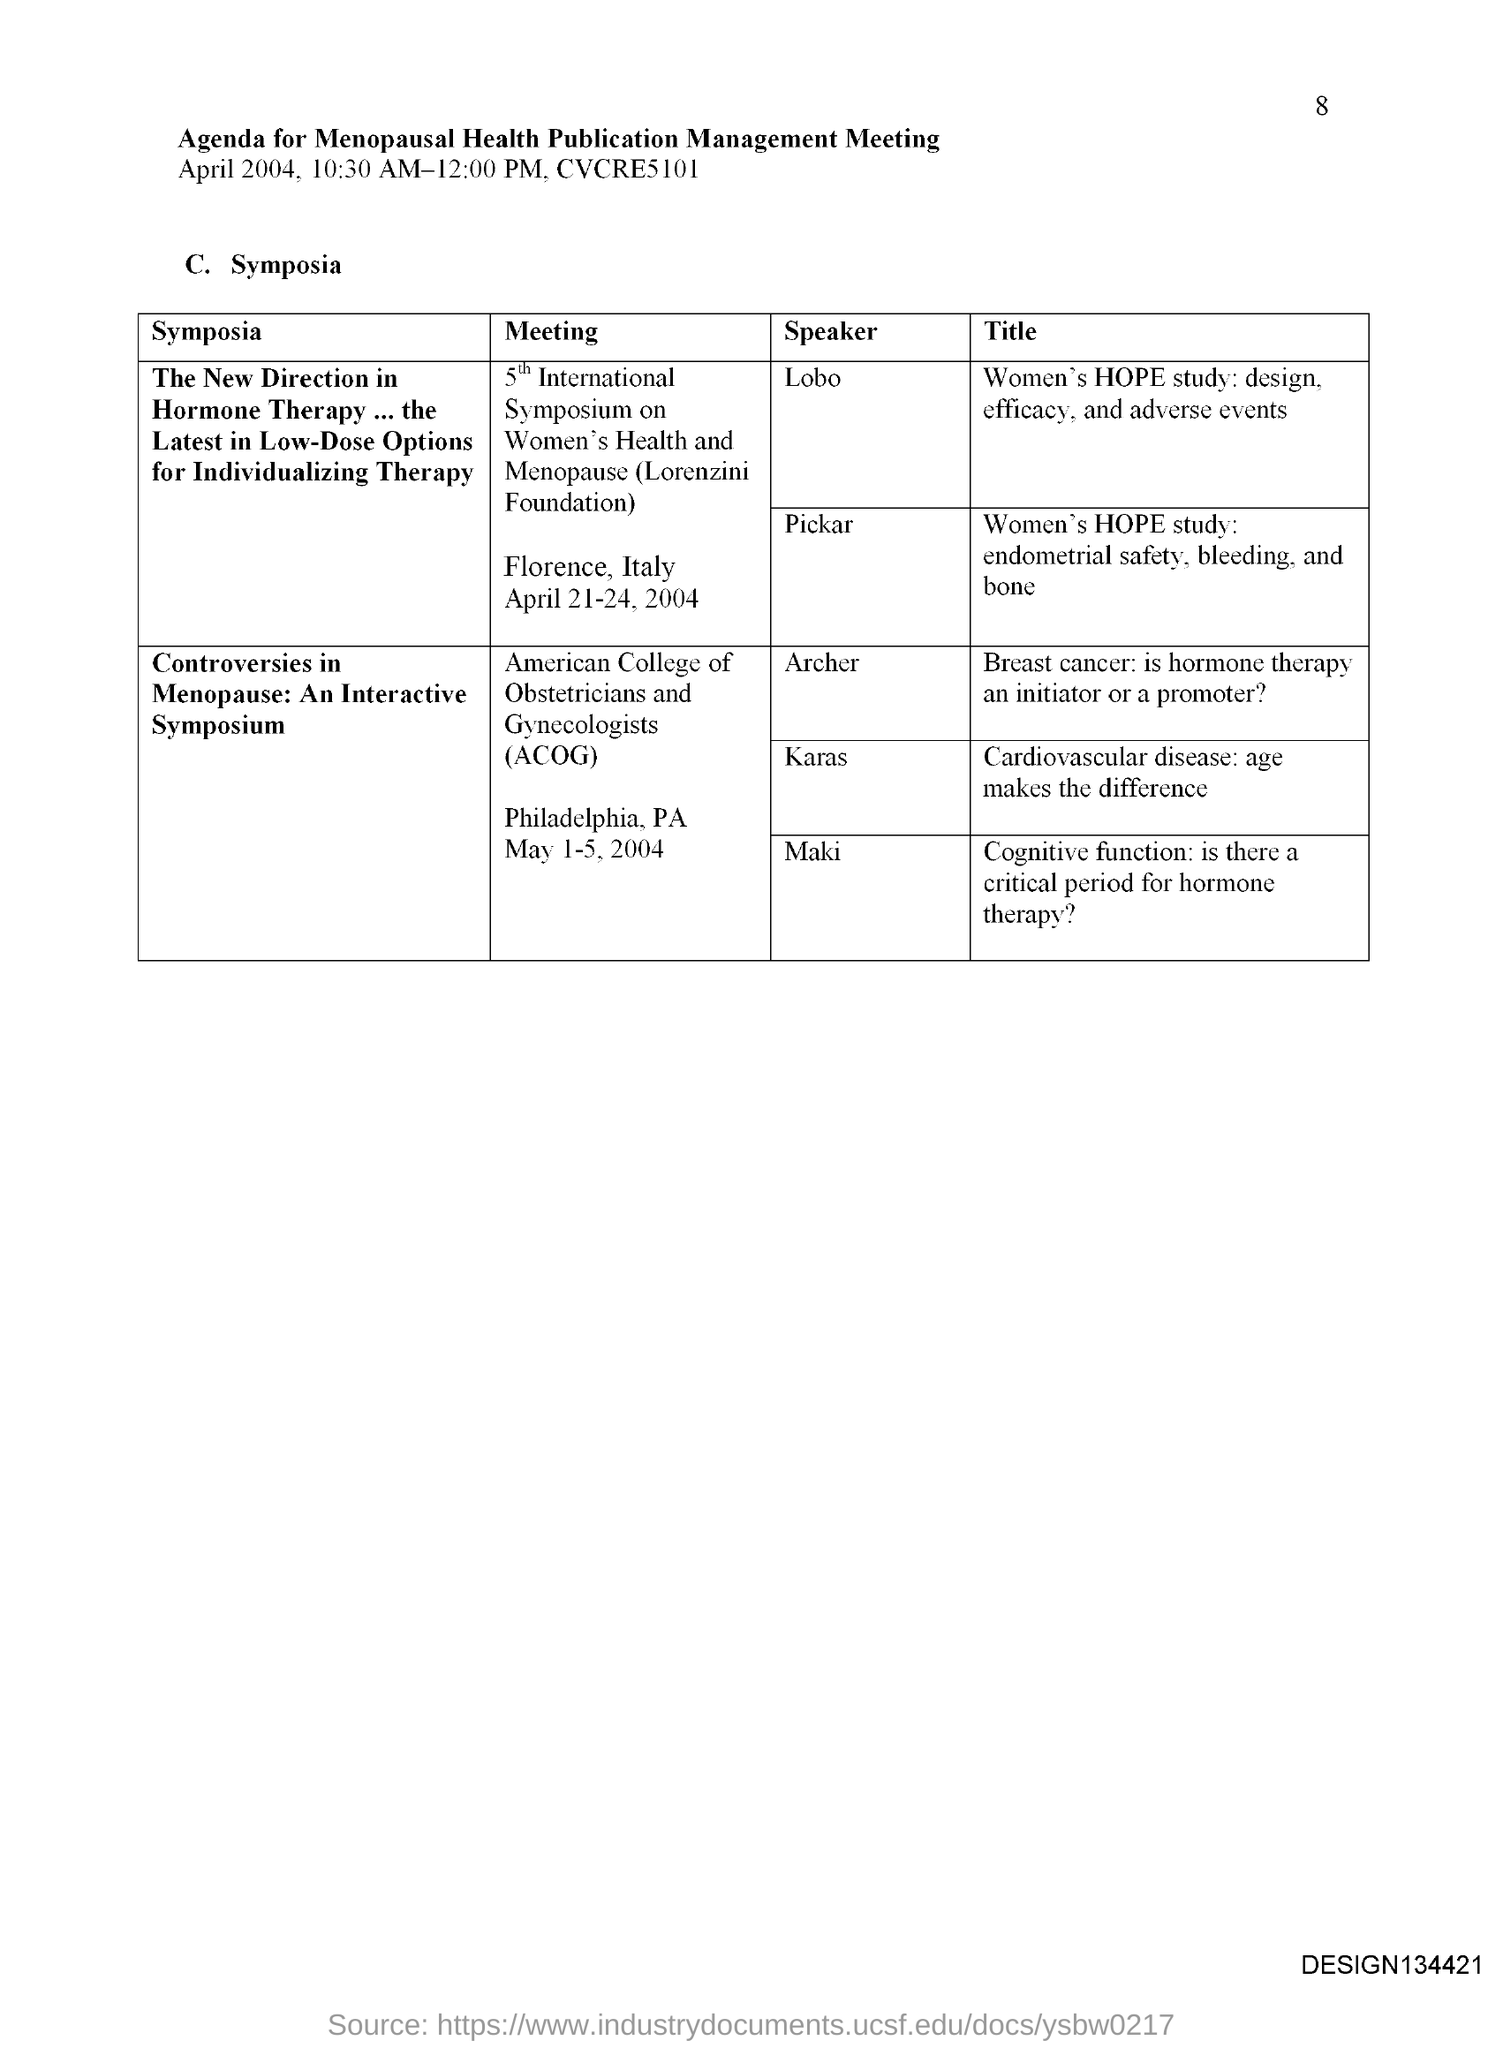What is the title of the document?
Make the answer very short. Agenda for Menopausal health publication management meeting. What is the Page Number?
Ensure brevity in your answer.  8. 